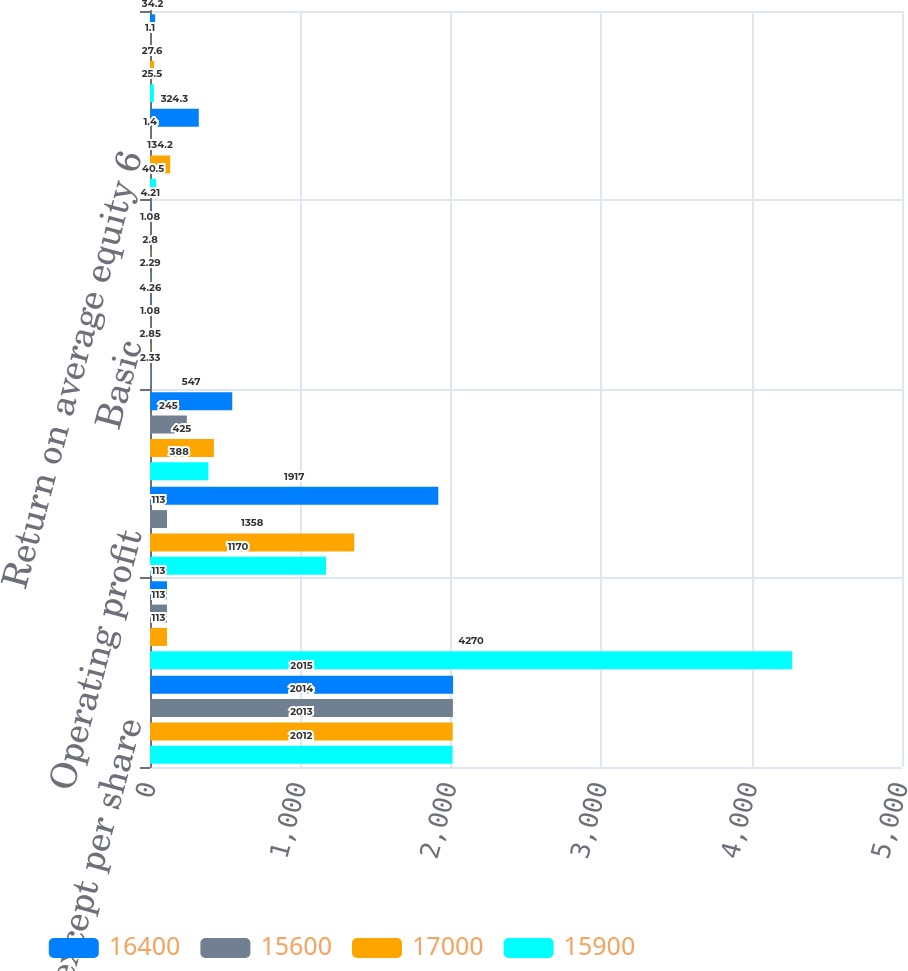<chart> <loc_0><loc_0><loc_500><loc_500><stacked_bar_chart><ecel><fcel>(in millions except per share<fcel>Revenue<fcel>Operating profit<fcel>Provision for taxes on income<fcel>Basic<fcel>Diluted<fcel>Return on average equity 6<fcel>Income from continuing<nl><fcel>16400<fcel>2015<fcel>113<fcel>1917<fcel>547<fcel>4.26<fcel>4.21<fcel>324.3<fcel>34.2<nl><fcel>15600<fcel>2014<fcel>113<fcel>113<fcel>245<fcel>1.08<fcel>1.08<fcel>1.4<fcel>1.1<nl><fcel>17000<fcel>2013<fcel>113<fcel>1358<fcel>425<fcel>2.85<fcel>2.8<fcel>134.2<fcel>27.6<nl><fcel>15900<fcel>2012<fcel>4270<fcel>1170<fcel>388<fcel>2.33<fcel>2.29<fcel>40.5<fcel>25.5<nl></chart> 